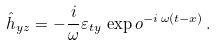Convert formula to latex. <formula><loc_0><loc_0><loc_500><loc_500>\hat { h } _ { y z } = - \frac { i } { \omega } \varepsilon _ { t y } \, \exp o ^ { - i \, \omega ( t - x ) } \, .</formula> 